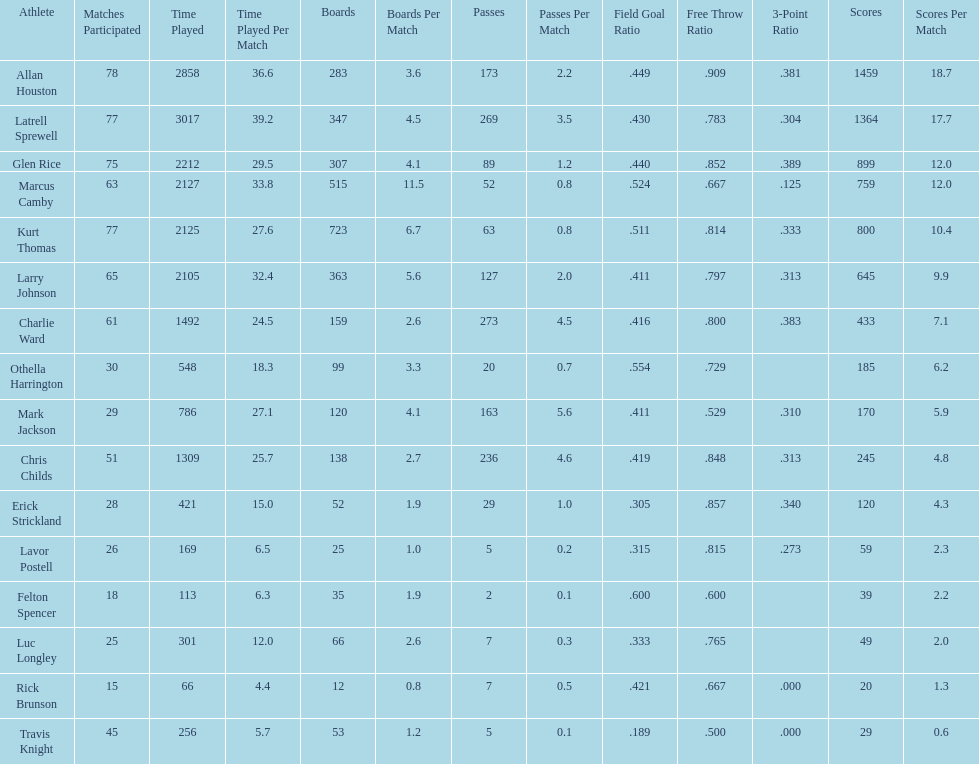Who scored more points, larry johnson or charlie ward? Larry Johnson. 